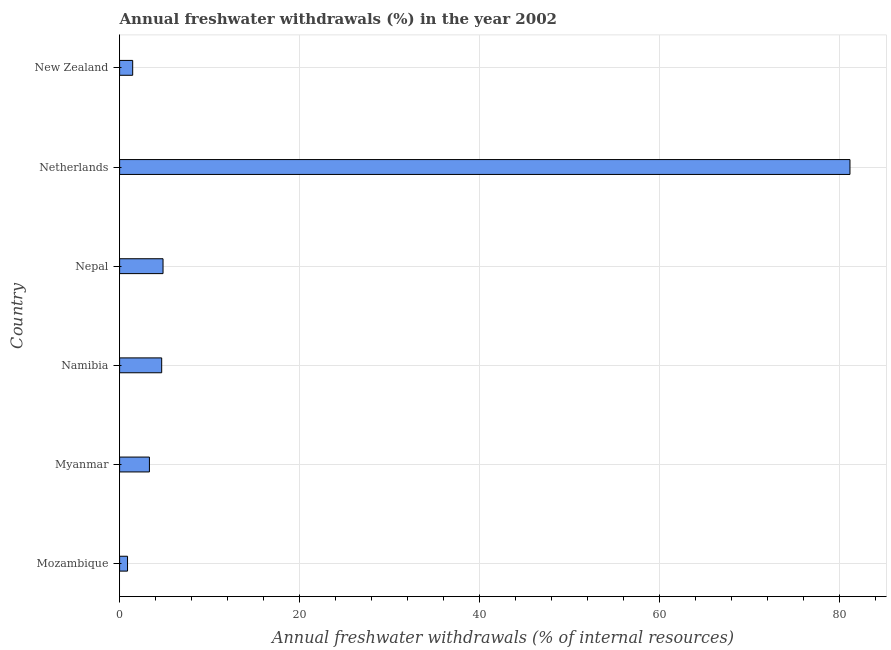Does the graph contain any zero values?
Offer a very short reply. No. What is the title of the graph?
Offer a very short reply. Annual freshwater withdrawals (%) in the year 2002. What is the label or title of the X-axis?
Give a very brief answer. Annual freshwater withdrawals (% of internal resources). What is the annual freshwater withdrawals in Namibia?
Give a very brief answer. 4.68. Across all countries, what is the maximum annual freshwater withdrawals?
Provide a succinct answer. 81.13. Across all countries, what is the minimum annual freshwater withdrawals?
Your answer should be compact. 0.88. In which country was the annual freshwater withdrawals minimum?
Offer a terse response. Mozambique. What is the sum of the annual freshwater withdrawals?
Your response must be concise. 96.28. What is the difference between the annual freshwater withdrawals in Myanmar and Netherlands?
Give a very brief answer. -77.81. What is the average annual freshwater withdrawals per country?
Keep it short and to the point. 16.05. What is the median annual freshwater withdrawals?
Provide a short and direct response. 3.99. In how many countries, is the annual freshwater withdrawals greater than 36 %?
Your answer should be very brief. 1. What is the ratio of the annual freshwater withdrawals in Mozambique to that in Myanmar?
Your answer should be very brief. 0.27. Is the difference between the annual freshwater withdrawals in Nepal and New Zealand greater than the difference between any two countries?
Give a very brief answer. No. What is the difference between the highest and the second highest annual freshwater withdrawals?
Keep it short and to the point. 76.3. Is the sum of the annual freshwater withdrawals in Mozambique and Namibia greater than the maximum annual freshwater withdrawals across all countries?
Keep it short and to the point. No. What is the difference between the highest and the lowest annual freshwater withdrawals?
Provide a short and direct response. 80.25. In how many countries, is the annual freshwater withdrawals greater than the average annual freshwater withdrawals taken over all countries?
Keep it short and to the point. 1. How many bars are there?
Make the answer very short. 6. Are all the bars in the graph horizontal?
Offer a terse response. Yes. How many countries are there in the graph?
Offer a terse response. 6. What is the difference between two consecutive major ticks on the X-axis?
Give a very brief answer. 20. Are the values on the major ticks of X-axis written in scientific E-notation?
Offer a very short reply. No. What is the Annual freshwater withdrawals (% of internal resources) of Mozambique?
Your response must be concise. 0.88. What is the Annual freshwater withdrawals (% of internal resources) of Myanmar?
Make the answer very short. 3.31. What is the Annual freshwater withdrawals (% of internal resources) of Namibia?
Give a very brief answer. 4.68. What is the Annual freshwater withdrawals (% of internal resources) in Nepal?
Make the answer very short. 4.82. What is the Annual freshwater withdrawals (% of internal resources) in Netherlands?
Your answer should be very brief. 81.13. What is the Annual freshwater withdrawals (% of internal resources) in New Zealand?
Your answer should be compact. 1.45. What is the difference between the Annual freshwater withdrawals (% of internal resources) in Mozambique and Myanmar?
Ensure brevity in your answer.  -2.43. What is the difference between the Annual freshwater withdrawals (% of internal resources) in Mozambique and Namibia?
Give a very brief answer. -3.79. What is the difference between the Annual freshwater withdrawals (% of internal resources) in Mozambique and Nepal?
Offer a very short reply. -3.94. What is the difference between the Annual freshwater withdrawals (% of internal resources) in Mozambique and Netherlands?
Your answer should be very brief. -80.25. What is the difference between the Annual freshwater withdrawals (% of internal resources) in Mozambique and New Zealand?
Offer a terse response. -0.57. What is the difference between the Annual freshwater withdrawals (% of internal resources) in Myanmar and Namibia?
Your answer should be very brief. -1.36. What is the difference between the Annual freshwater withdrawals (% of internal resources) in Myanmar and Nepal?
Provide a short and direct response. -1.51. What is the difference between the Annual freshwater withdrawals (% of internal resources) in Myanmar and Netherlands?
Keep it short and to the point. -77.81. What is the difference between the Annual freshwater withdrawals (% of internal resources) in Myanmar and New Zealand?
Keep it short and to the point. 1.86. What is the difference between the Annual freshwater withdrawals (% of internal resources) in Namibia and Nepal?
Give a very brief answer. -0.15. What is the difference between the Annual freshwater withdrawals (% of internal resources) in Namibia and Netherlands?
Ensure brevity in your answer.  -76.45. What is the difference between the Annual freshwater withdrawals (% of internal resources) in Namibia and New Zealand?
Provide a succinct answer. 3.22. What is the difference between the Annual freshwater withdrawals (% of internal resources) in Nepal and Netherlands?
Keep it short and to the point. -76.3. What is the difference between the Annual freshwater withdrawals (% of internal resources) in Nepal and New Zealand?
Keep it short and to the point. 3.37. What is the difference between the Annual freshwater withdrawals (% of internal resources) in Netherlands and New Zealand?
Make the answer very short. 79.67. What is the ratio of the Annual freshwater withdrawals (% of internal resources) in Mozambique to that in Myanmar?
Your answer should be compact. 0.27. What is the ratio of the Annual freshwater withdrawals (% of internal resources) in Mozambique to that in Namibia?
Make the answer very short. 0.19. What is the ratio of the Annual freshwater withdrawals (% of internal resources) in Mozambique to that in Nepal?
Give a very brief answer. 0.18. What is the ratio of the Annual freshwater withdrawals (% of internal resources) in Mozambique to that in Netherlands?
Offer a very short reply. 0.01. What is the ratio of the Annual freshwater withdrawals (% of internal resources) in Mozambique to that in New Zealand?
Offer a very short reply. 0.61. What is the ratio of the Annual freshwater withdrawals (% of internal resources) in Myanmar to that in Namibia?
Ensure brevity in your answer.  0.71. What is the ratio of the Annual freshwater withdrawals (% of internal resources) in Myanmar to that in Nepal?
Your response must be concise. 0.69. What is the ratio of the Annual freshwater withdrawals (% of internal resources) in Myanmar to that in Netherlands?
Your answer should be compact. 0.04. What is the ratio of the Annual freshwater withdrawals (% of internal resources) in Myanmar to that in New Zealand?
Your answer should be compact. 2.28. What is the ratio of the Annual freshwater withdrawals (% of internal resources) in Namibia to that in Nepal?
Offer a terse response. 0.97. What is the ratio of the Annual freshwater withdrawals (% of internal resources) in Namibia to that in Netherlands?
Offer a very short reply. 0.06. What is the ratio of the Annual freshwater withdrawals (% of internal resources) in Namibia to that in New Zealand?
Your answer should be very brief. 3.22. What is the ratio of the Annual freshwater withdrawals (% of internal resources) in Nepal to that in Netherlands?
Offer a very short reply. 0.06. What is the ratio of the Annual freshwater withdrawals (% of internal resources) in Nepal to that in New Zealand?
Keep it short and to the point. 3.32. What is the ratio of the Annual freshwater withdrawals (% of internal resources) in Netherlands to that in New Zealand?
Give a very brief answer. 55.81. 